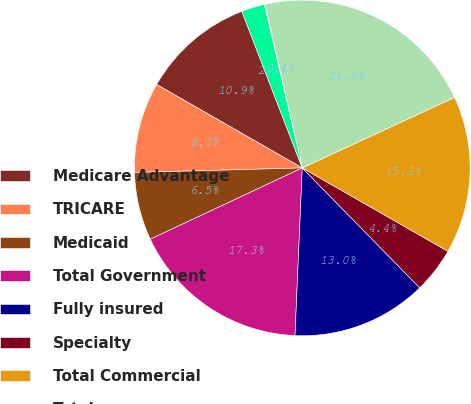<chart> <loc_0><loc_0><loc_500><loc_500><pie_chart><fcel>Medicare Advantage<fcel>TRICARE<fcel>Medicaid<fcel>Total Government<fcel>Fully insured<fcel>Specialty<fcel>Total Commercial<fcel>Total<fcel>Government<fcel>Commercial<nl><fcel>10.86%<fcel>8.71%<fcel>6.55%<fcel>17.33%<fcel>13.02%<fcel>4.39%<fcel>15.18%<fcel>21.65%<fcel>0.08%<fcel>2.23%<nl></chart> 